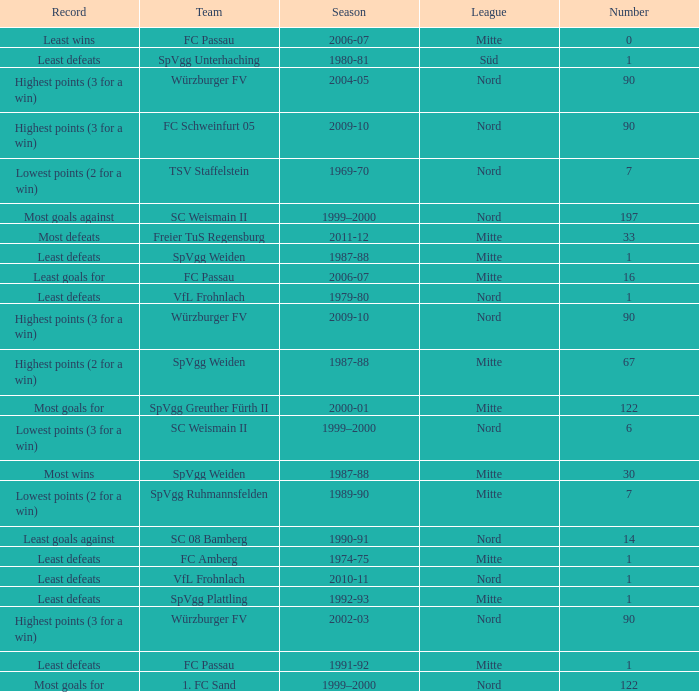What league has a number less than 122, and least wins as the record? Mitte. 